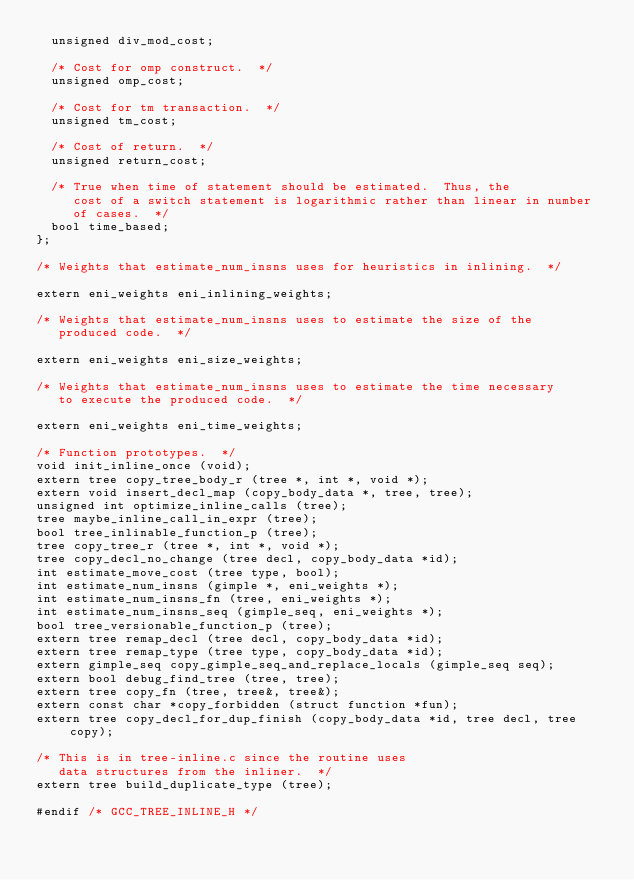Convert code to text. <code><loc_0><loc_0><loc_500><loc_500><_C_>  unsigned div_mod_cost;

  /* Cost for omp construct.  */
  unsigned omp_cost;

  /* Cost for tm transaction.  */
  unsigned tm_cost;

  /* Cost of return.  */
  unsigned return_cost;

  /* True when time of statement should be estimated.  Thus, the
     cost of a switch statement is logarithmic rather than linear in number
     of cases.  */
  bool time_based;
};

/* Weights that estimate_num_insns uses for heuristics in inlining.  */

extern eni_weights eni_inlining_weights;

/* Weights that estimate_num_insns uses to estimate the size of the
   produced code.  */

extern eni_weights eni_size_weights;

/* Weights that estimate_num_insns uses to estimate the time necessary
   to execute the produced code.  */

extern eni_weights eni_time_weights;

/* Function prototypes.  */
void init_inline_once (void);
extern tree copy_tree_body_r (tree *, int *, void *);
extern void insert_decl_map (copy_body_data *, tree, tree);
unsigned int optimize_inline_calls (tree);
tree maybe_inline_call_in_expr (tree);
bool tree_inlinable_function_p (tree);
tree copy_tree_r (tree *, int *, void *);
tree copy_decl_no_change (tree decl, copy_body_data *id);
int estimate_move_cost (tree type, bool);
int estimate_num_insns (gimple *, eni_weights *);
int estimate_num_insns_fn (tree, eni_weights *);
int estimate_num_insns_seq (gimple_seq, eni_weights *);
bool tree_versionable_function_p (tree);
extern tree remap_decl (tree decl, copy_body_data *id);
extern tree remap_type (tree type, copy_body_data *id);
extern gimple_seq copy_gimple_seq_and_replace_locals (gimple_seq seq);
extern bool debug_find_tree (tree, tree);
extern tree copy_fn (tree, tree&, tree&);
extern const char *copy_forbidden (struct function *fun);
extern tree copy_decl_for_dup_finish (copy_body_data *id, tree decl, tree copy);

/* This is in tree-inline.c since the routine uses
   data structures from the inliner.  */
extern tree build_duplicate_type (tree);

#endif /* GCC_TREE_INLINE_H */
</code> 